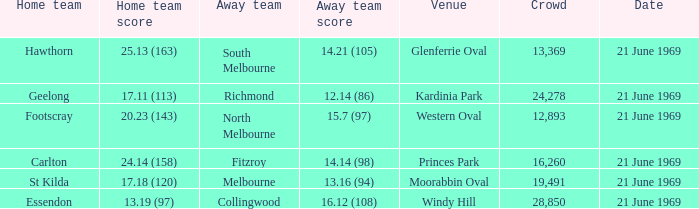When did an away team score 15.7 (97)? 21 June 1969. 